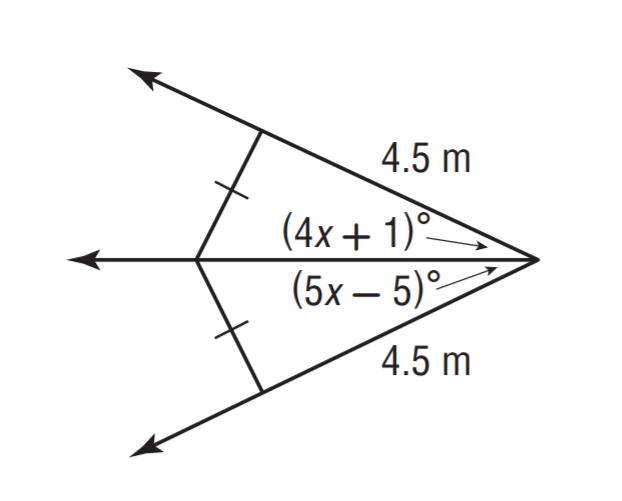Answer the mathemtical geometry problem and directly provide the correct option letter.
Question: Solve for x.
Choices: A: 3 B: 4 C: 5 D: 6 D 